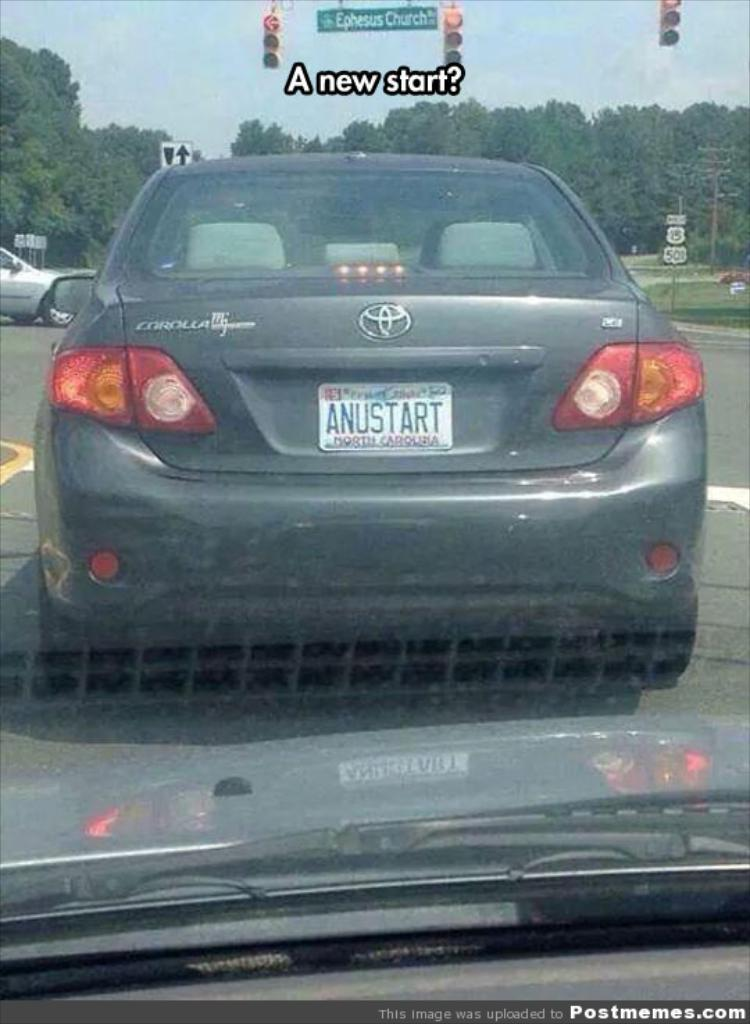<image>
Write a terse but informative summary of the picture. A gray Corolla waits at a stop light showing a red arrow. 